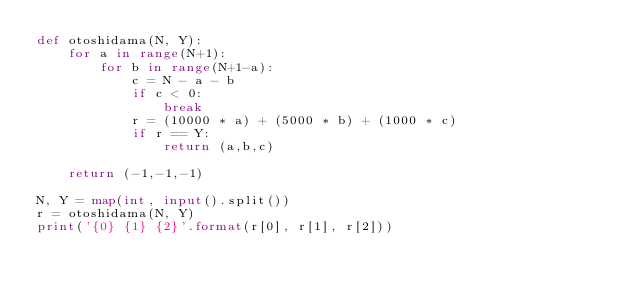Convert code to text. <code><loc_0><loc_0><loc_500><loc_500><_Python_>def otoshidama(N, Y):
    for a in range(N+1):
        for b in range(N+1-a):
            c = N - a - b
            if c < 0:
                break
            r = (10000 * a) + (5000 * b) + (1000 * c)
            if r == Y:
                return (a,b,c)

    return (-1,-1,-1)

N, Y = map(int, input().split())
r = otoshidama(N, Y)
print('{0} {1} {2}'.format(r[0], r[1], r[2]))
</code> 